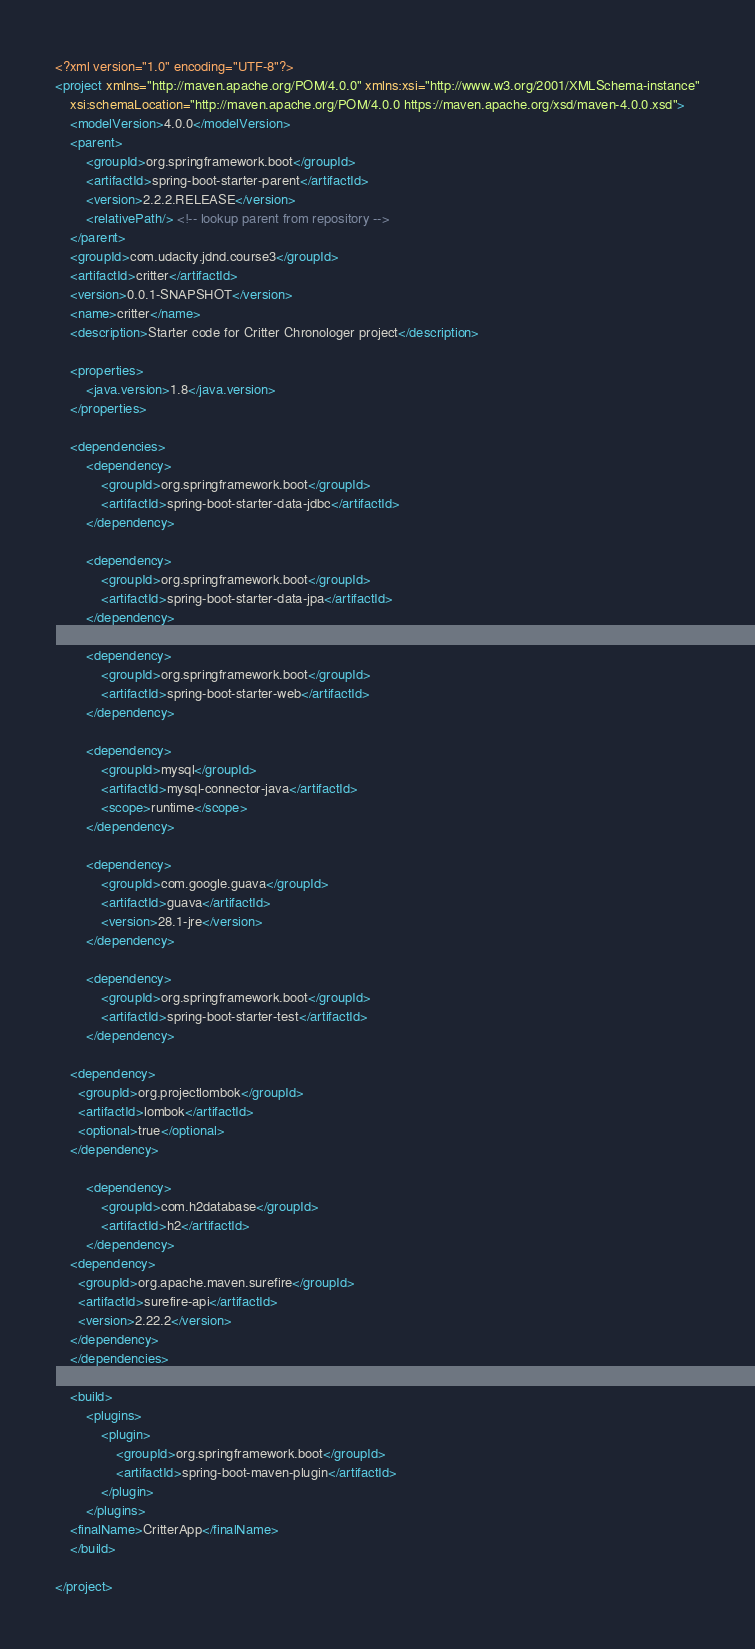<code> <loc_0><loc_0><loc_500><loc_500><_XML_><?xml version="1.0" encoding="UTF-8"?>
<project xmlns="http://maven.apache.org/POM/4.0.0" xmlns:xsi="http://www.w3.org/2001/XMLSchema-instance"
	xsi:schemaLocation="http://maven.apache.org/POM/4.0.0 https://maven.apache.org/xsd/maven-4.0.0.xsd">
	<modelVersion>4.0.0</modelVersion>
	<parent>
		<groupId>org.springframework.boot</groupId>
		<artifactId>spring-boot-starter-parent</artifactId>
		<version>2.2.2.RELEASE</version>
		<relativePath/> <!-- lookup parent from repository -->
	</parent>
	<groupId>com.udacity.jdnd.course3</groupId>
	<artifactId>critter</artifactId>
	<version>0.0.1-SNAPSHOT</version>
	<name>critter</name>
	<description>Starter code for Critter Chronologer project</description>

	<properties>
		<java.version>1.8</java.version>
	</properties>

	<dependencies>
		<dependency>
			<groupId>org.springframework.boot</groupId>
			<artifactId>spring-boot-starter-data-jdbc</artifactId>
		</dependency>

		<dependency>
			<groupId>org.springframework.boot</groupId>
			<artifactId>spring-boot-starter-data-jpa</artifactId>
		</dependency>

		<dependency>
			<groupId>org.springframework.boot</groupId>
			<artifactId>spring-boot-starter-web</artifactId>
		</dependency>

		<dependency>
			<groupId>mysql</groupId>
			<artifactId>mysql-connector-java</artifactId>
			<scope>runtime</scope>
		</dependency>

		<dependency>
			<groupId>com.google.guava</groupId>
			<artifactId>guava</artifactId>
			<version>28.1-jre</version>
		</dependency>

		<dependency>
			<groupId>org.springframework.boot</groupId>
			<artifactId>spring-boot-starter-test</artifactId>
		</dependency>

    <dependency>
      <groupId>org.projectlombok</groupId>
      <artifactId>lombok</artifactId>
      <optional>true</optional>
    </dependency>

		<dependency>
			<groupId>com.h2database</groupId>
			<artifactId>h2</artifactId>
		</dependency>
    <dependency>
      <groupId>org.apache.maven.surefire</groupId>
      <artifactId>surefire-api</artifactId>
      <version>2.22.2</version>
    </dependency>
	</dependencies>

	<build>
		<plugins>
			<plugin>
				<groupId>org.springframework.boot</groupId>
				<artifactId>spring-boot-maven-plugin</artifactId>
			</plugin>
		</plugins>
    <finalName>CritterApp</finalName>
	</build>

</project>
</code> 